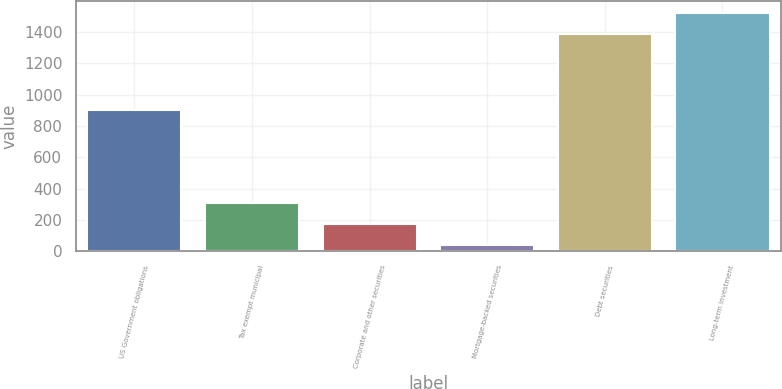Convert chart. <chart><loc_0><loc_0><loc_500><loc_500><bar_chart><fcel>US Government obligations<fcel>Tax exempt municipal<fcel>Corporate and other securities<fcel>Mortgage-backed securities<fcel>Debt securities<fcel>Long-term investment<nl><fcel>901<fcel>307.2<fcel>172.1<fcel>37<fcel>1388<fcel>1523.1<nl></chart> 